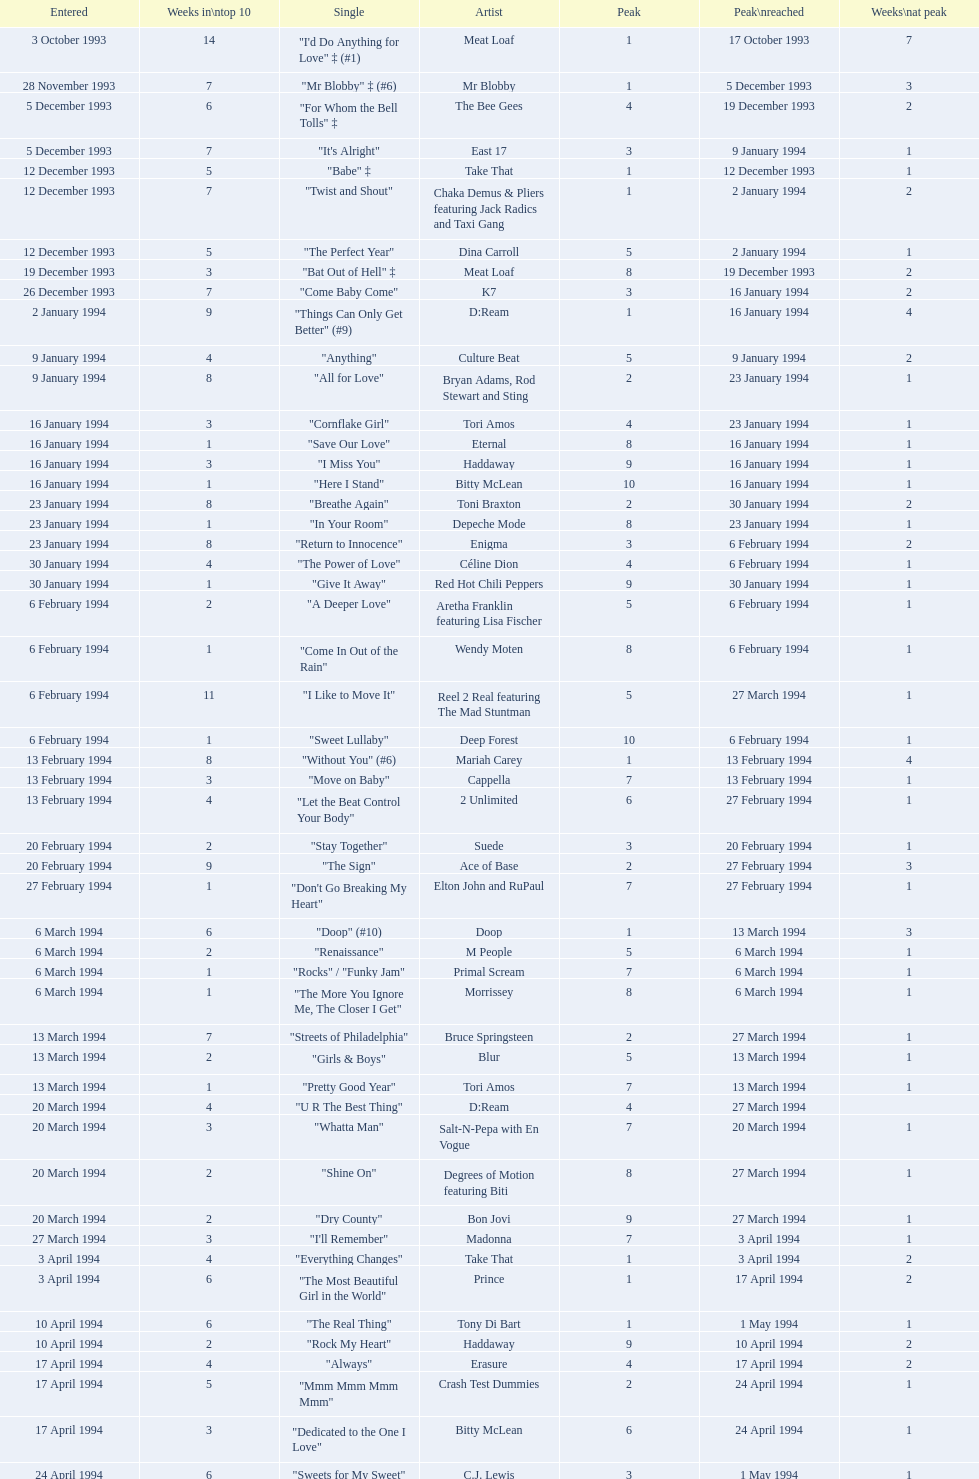This track put out by celine dion was on the uk singles chart for 17 weeks in 1994, what is its title? "Think Twice". 